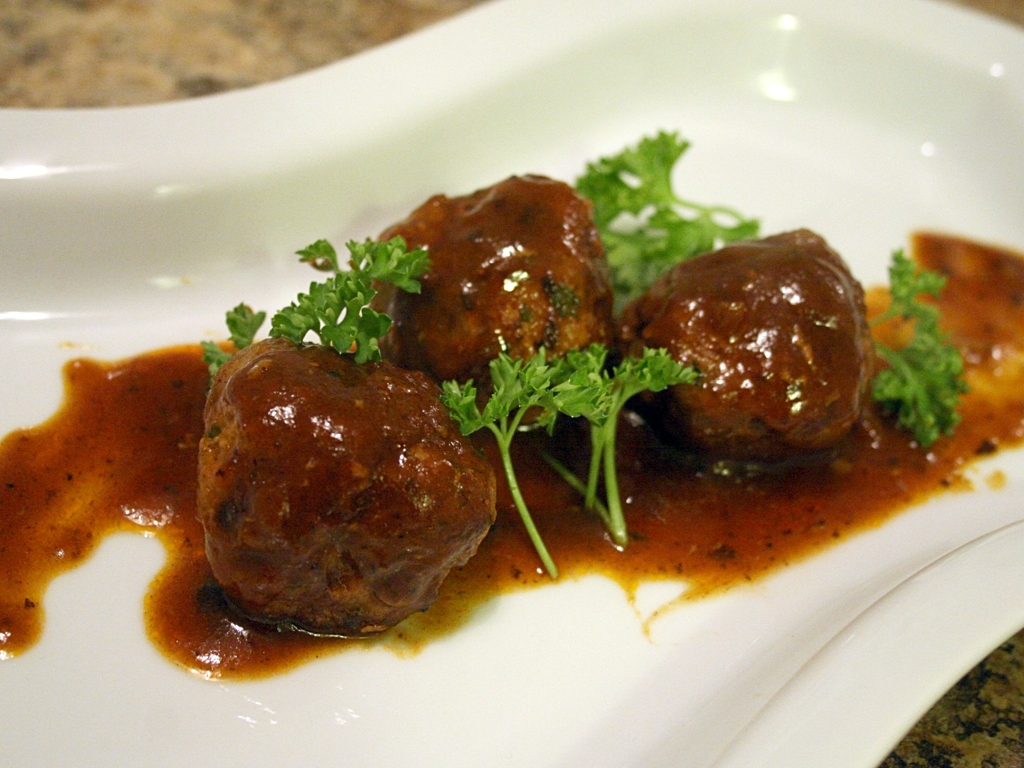What could be the setting for enjoying this meal? This meal, with its hearty and warming appearance, seems ideal for a cozy dinner setting, possibly enjoyed at an intimate family table or a casual dining restaurant. Its presentation suggests a homely comfort that would be suitable for colder weather or a relaxed weekend meal. 